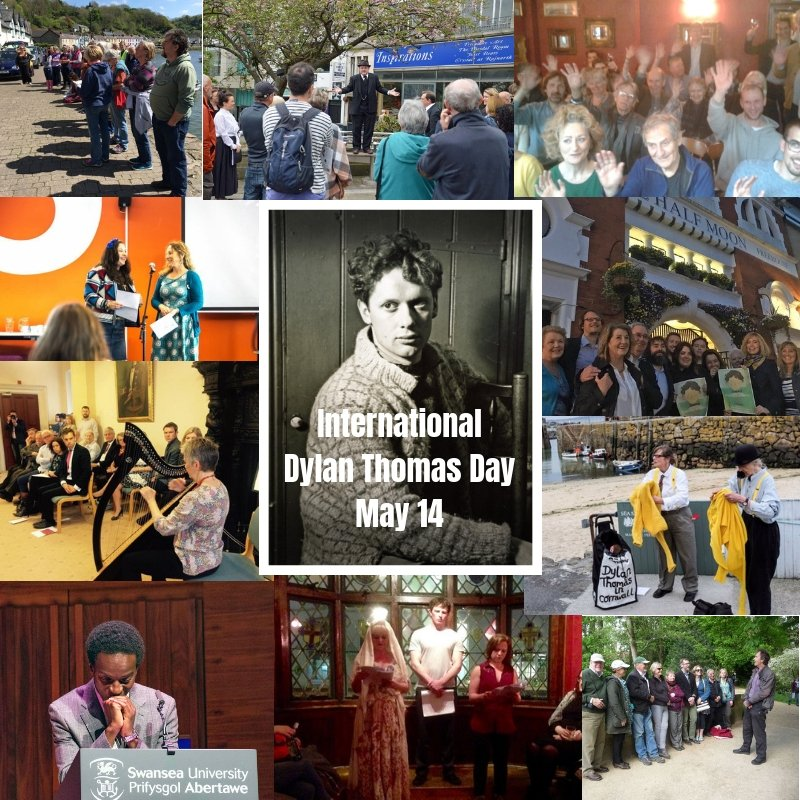Imagine you are part of the event in the bottom left image. What would the experience be like? Joining the event in the bottom left image, you would find yourself in an elegant setting, possibly a historical or cultural venue, where a distinguished speaker is giving a thoughtful presentation at a podium with the Swansea University logo. The atmosphere would be one of intellectual engagement, with attendees listening intently, taking notes, and perhaps even participating in a question-and-answer session. You might feel a sense of connection to Dylan Thomas's legacy, immersed in deep reflections on his literary contributions and their ongoing impact. 